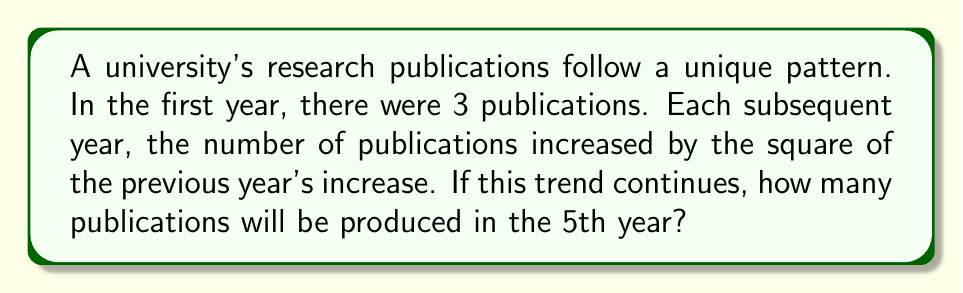Show me your answer to this math problem. Let's analyze this step-by-step:

1) Year 1: 3 publications
   Initial increase: Not applicable

2) Year 2:
   Previous increase: Not applicable (assume 0)
   New increase: $0^2 = 0$
   Publications: $3 + 0 = 3$

3) Year 3:
   Previous increase: 0
   New increase: $0^2 = 0$
   Publications: $3 + 0 = 3$

4) Year 4:
   Previous increase: 0
   New increase: $0^2 = 0$
   Publications: $3 + 0 = 3$

5) Year 5:
   Previous increase: 0
   New increase: $0^2 = 0$
   Publications: $3 + 0 = 3$

Therefore, the pattern shows that the number of publications remains constant at 3 each year.

This unconventional sequence might raise eyebrows, as it doesn't show the expected growth in research output. However, it demonstrates the importance of careful analysis and not assuming growth without evidence.
Answer: 3 publications 